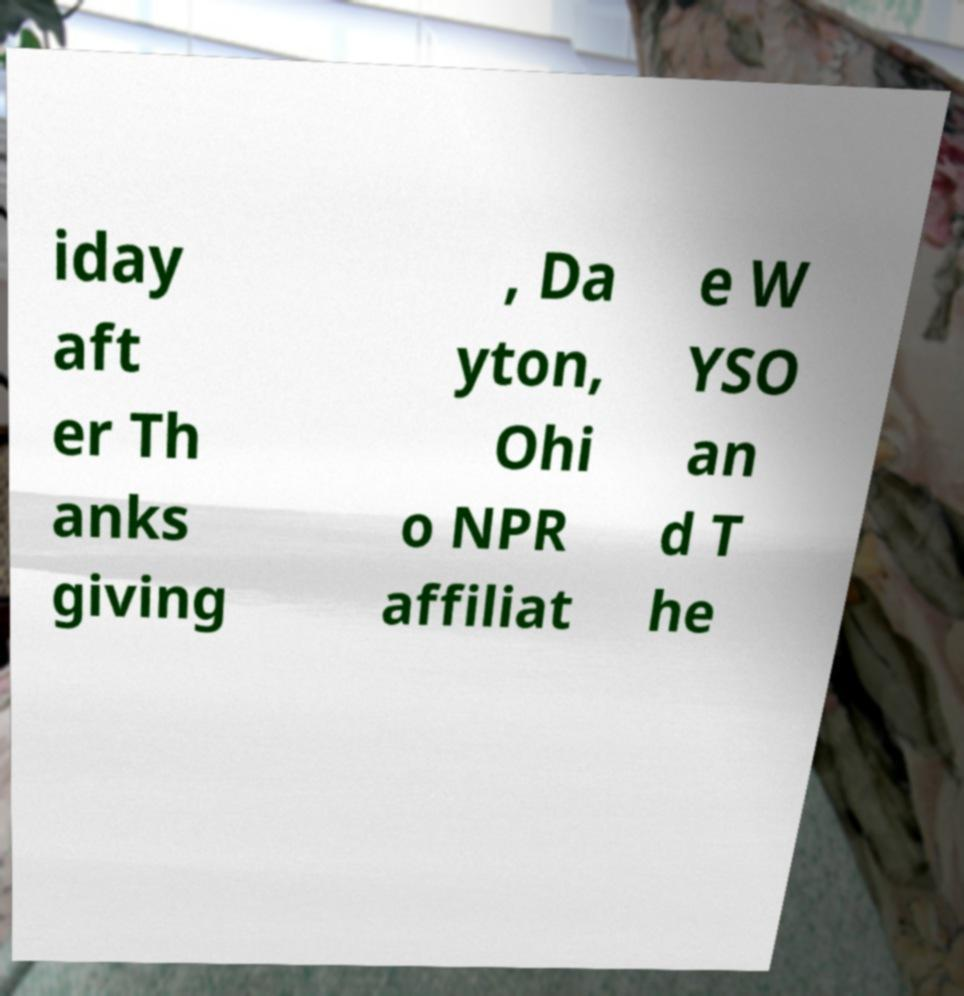Could you extract and type out the text from this image? iday aft er Th anks giving , Da yton, Ohi o NPR affiliat e W YSO an d T he 